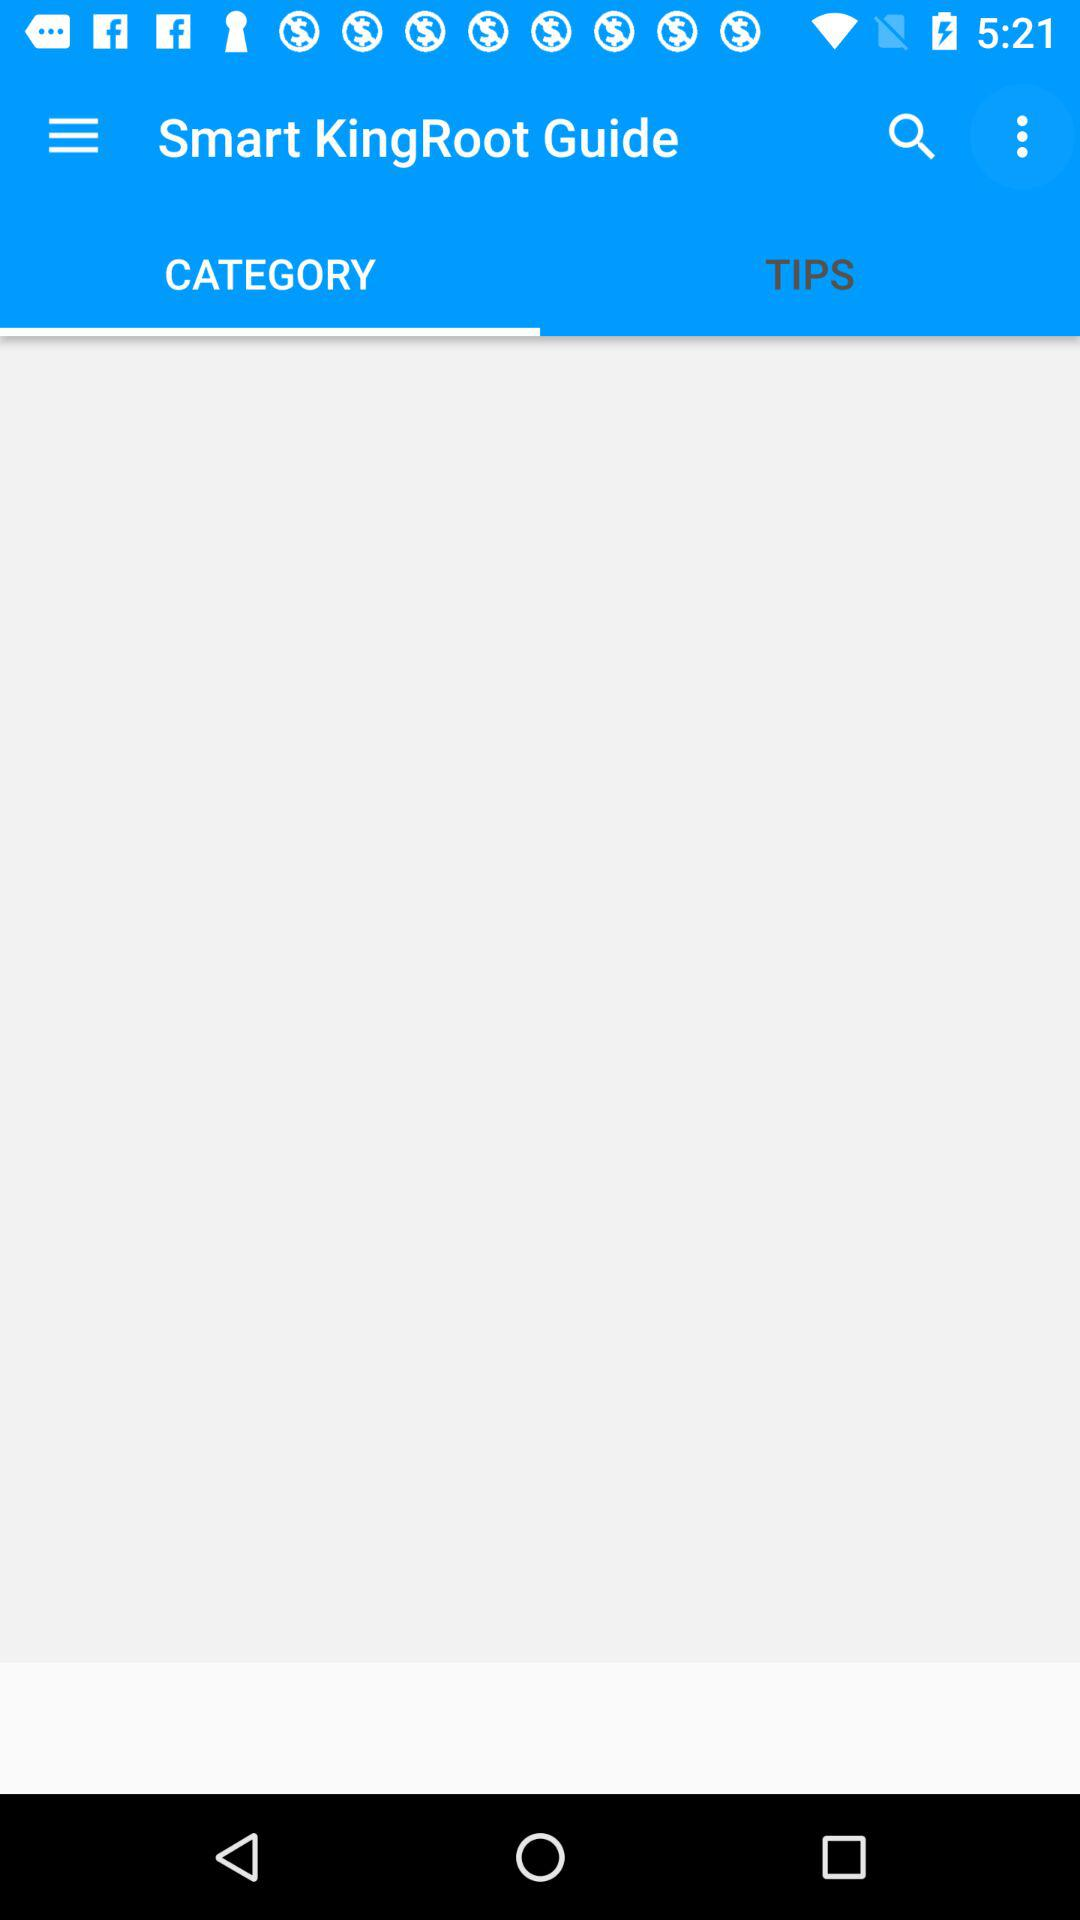When was "Smart KingRoot Guide" last updated?
When the provided information is insufficient, respond with <no answer>. <no answer> 